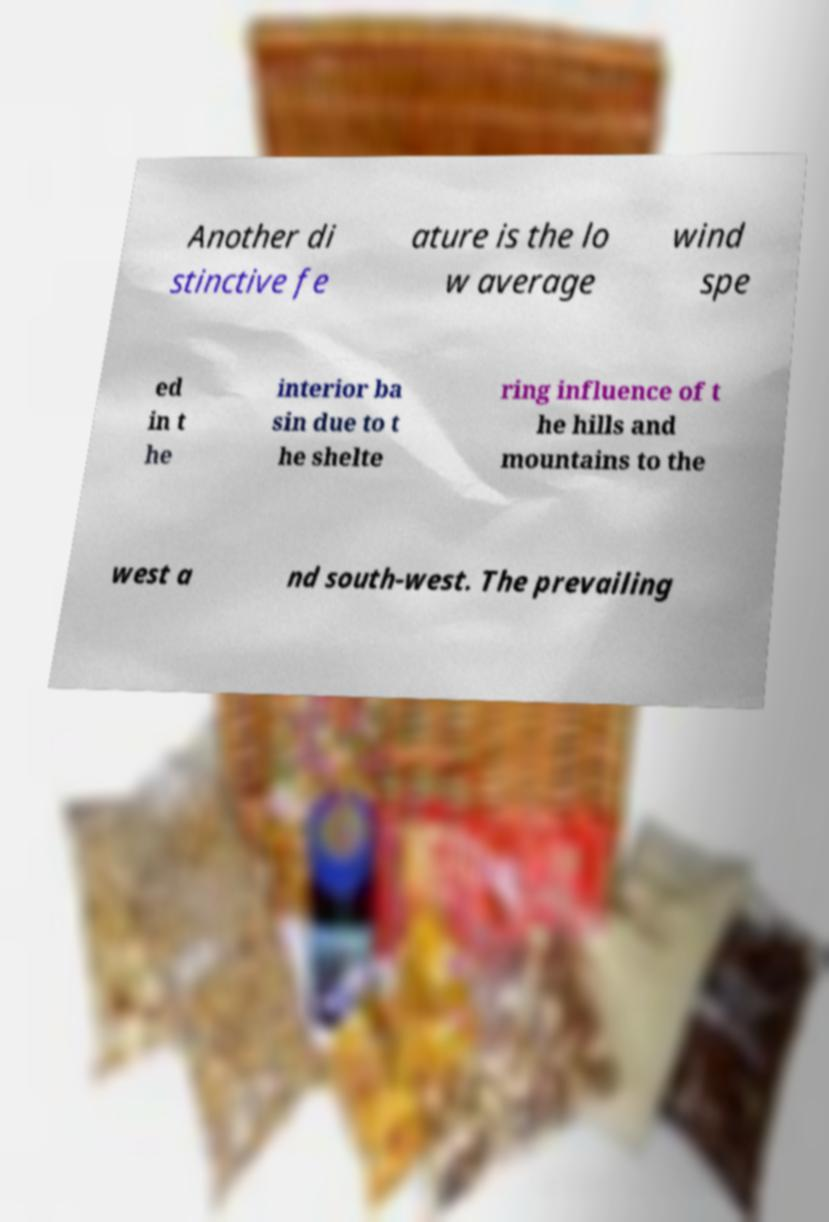Could you assist in decoding the text presented in this image and type it out clearly? Another di stinctive fe ature is the lo w average wind spe ed in t he interior ba sin due to t he shelte ring influence of t he hills and mountains to the west a nd south-west. The prevailing 